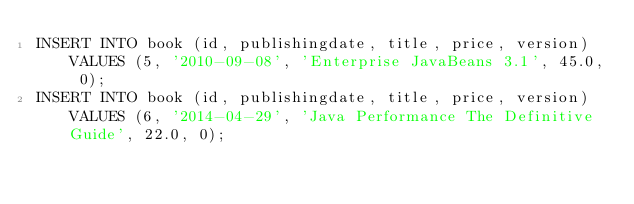Convert code to text. <code><loc_0><loc_0><loc_500><loc_500><_SQL_>INSERT INTO book (id, publishingdate, title, price, version) VALUES (5, '2010-09-08', 'Enterprise JavaBeans 3.1', 45.0, 0);
INSERT INTO book (id, publishingdate, title, price, version) VALUES (6, '2014-04-29', 'Java Performance The Definitive Guide', 22.0, 0);</code> 